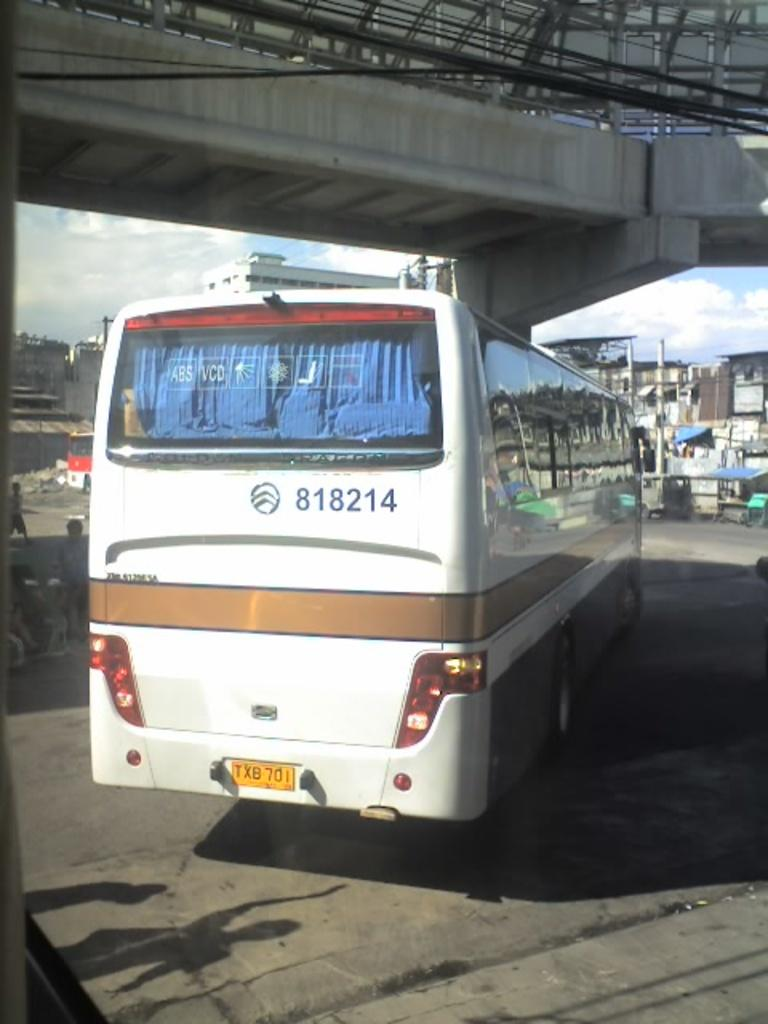What is the main subject of the image? The main subject of the image is a bus. What else can be seen in the image besides the bus? There is a bridge, people near the bus, buildings in the background, and poles in the background. What type of collar can be seen on the bus in the image? There is no collar present on the bus in the image. How many buckets are visible on the bridge in the image? There are no buckets visible in the image; it features a bus, a bridge, people, buildings, and poles. 